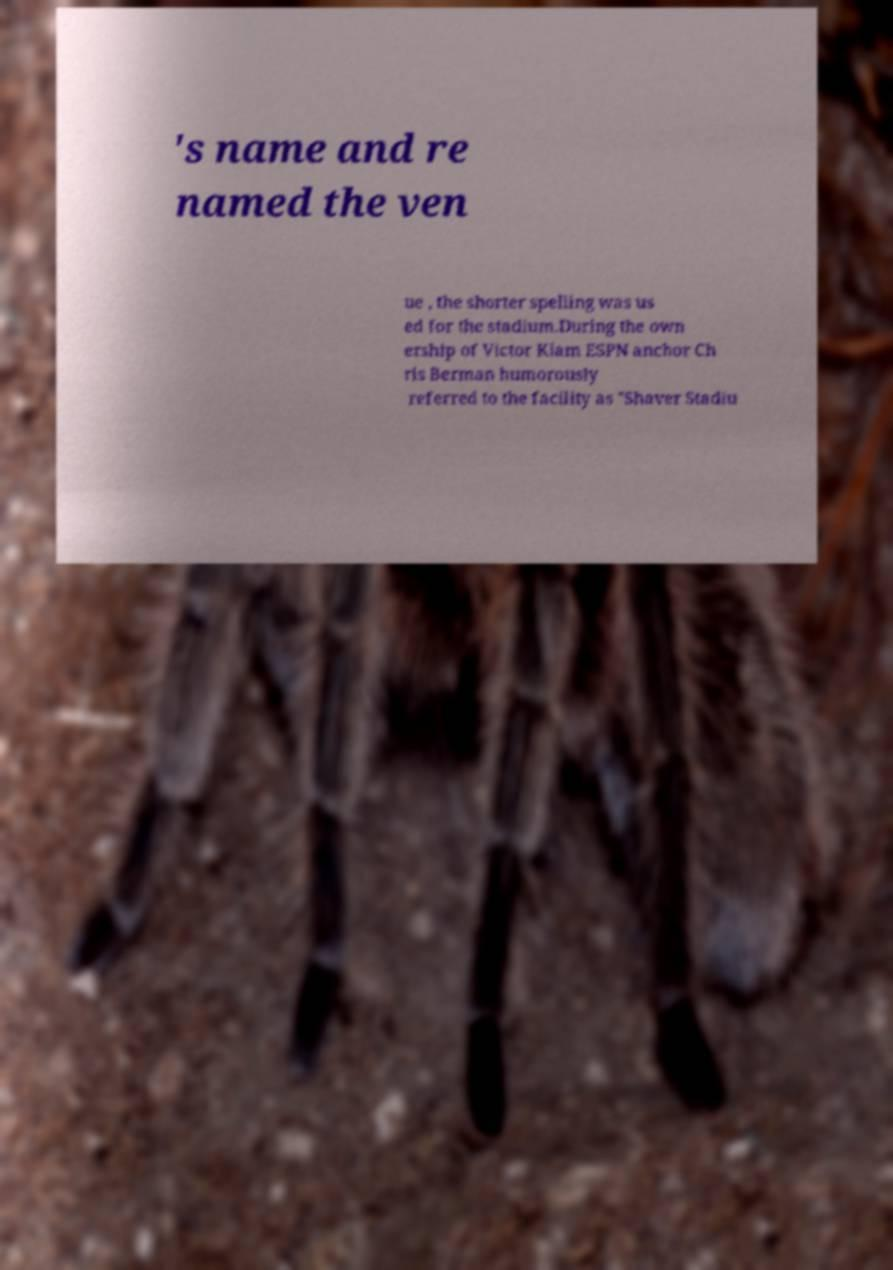Could you extract and type out the text from this image? 's name and re named the ven ue , the shorter spelling was us ed for the stadium.During the own ership of Victor Kiam ESPN anchor Ch ris Berman humorously referred to the facility as "Shaver Stadiu 